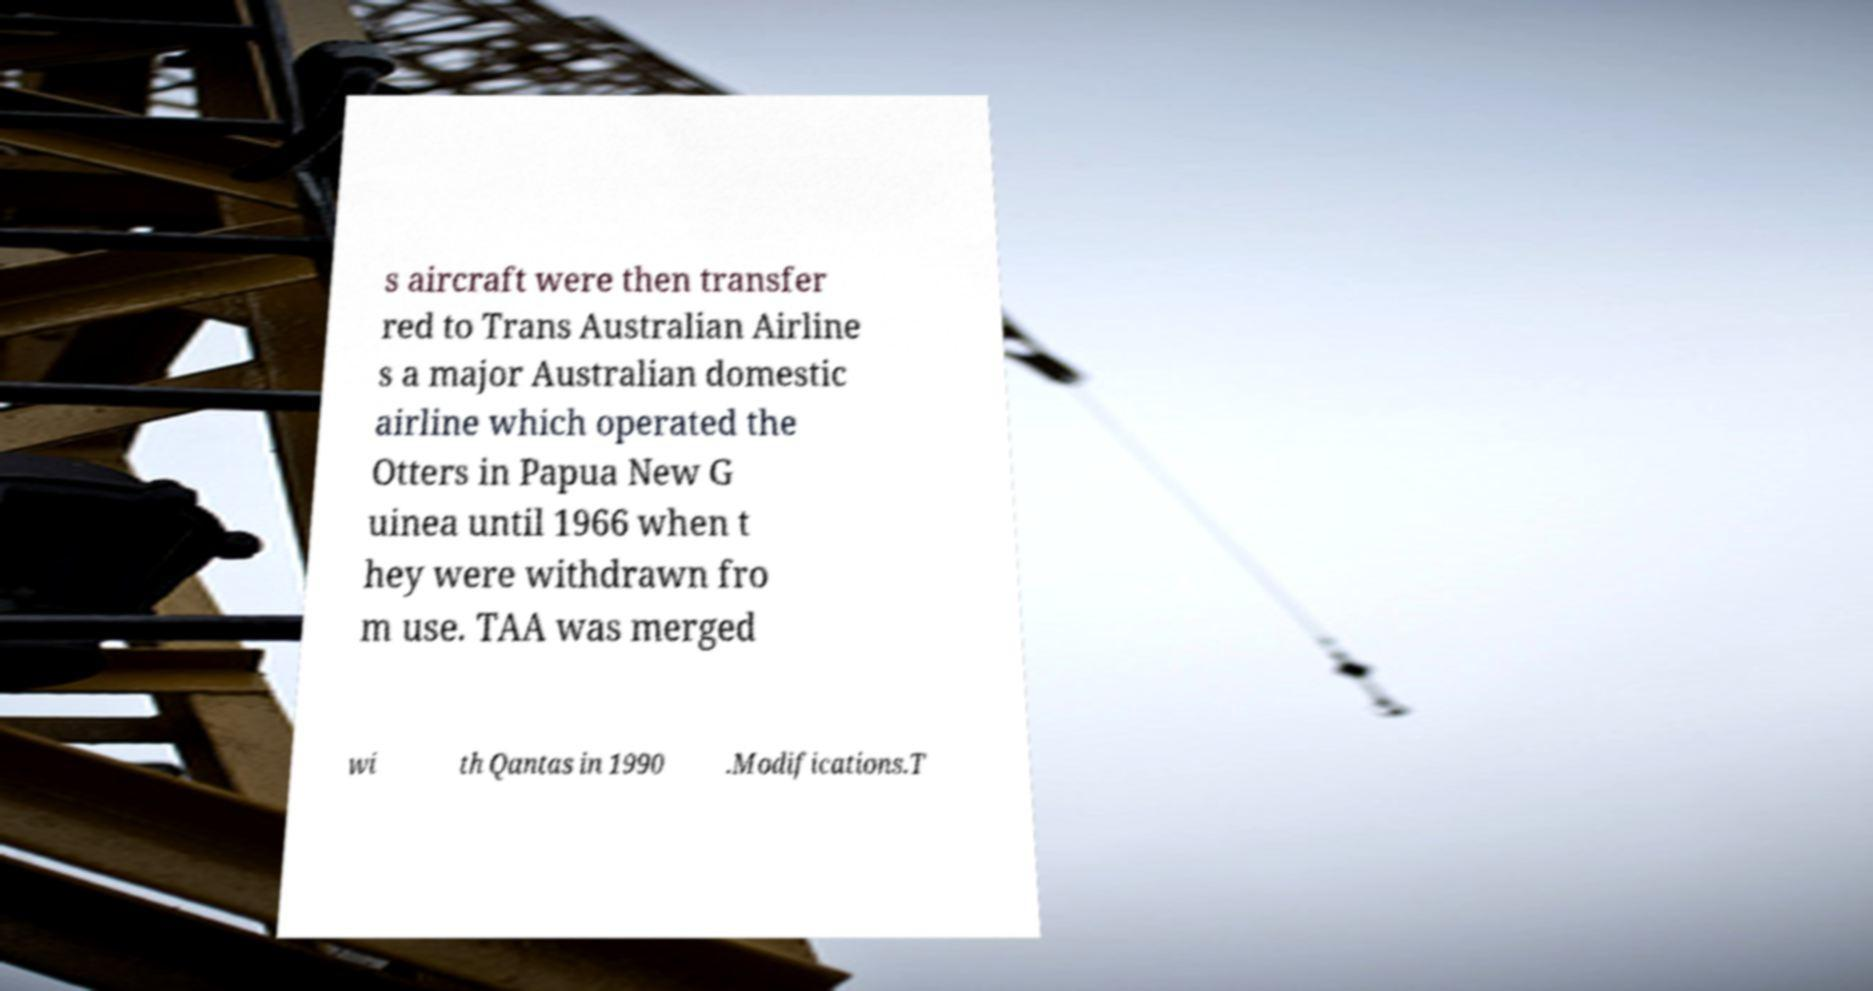What messages or text are displayed in this image? I need them in a readable, typed format. s aircraft were then transfer red to Trans Australian Airline s a major Australian domestic airline which operated the Otters in Papua New G uinea until 1966 when t hey were withdrawn fro m use. TAA was merged wi th Qantas in 1990 .Modifications.T 